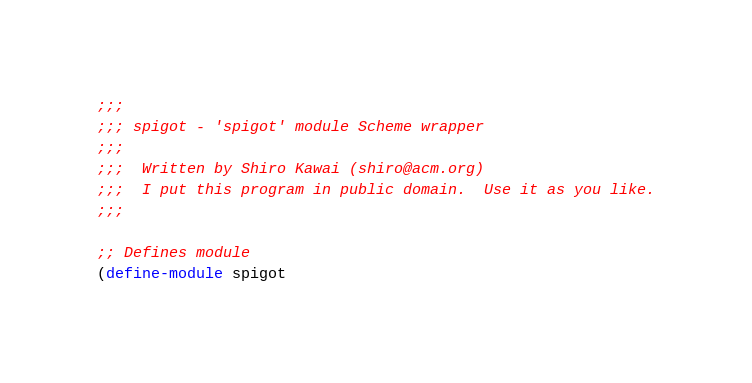Convert code to text. <code><loc_0><loc_0><loc_500><loc_500><_Scheme_>;;;
;;; spigot - 'spigot' module Scheme wrapper
;;;
;;;  Written by Shiro Kawai (shiro@acm.org)
;;;  I put this program in public domain.  Use it as you like.
;;;

;; Defines module
(define-module spigot</code> 